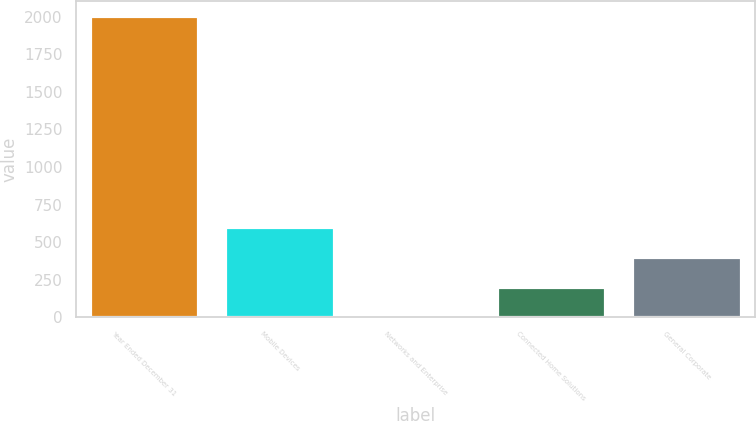Convert chart. <chart><loc_0><loc_0><loc_500><loc_500><bar_chart><fcel>Year Ended December 31<fcel>Mobile Devices<fcel>Networks and Enterprise<fcel>Connected Home Solutions<fcel>General Corporate<nl><fcel>2004<fcel>602.6<fcel>2<fcel>202.2<fcel>402.4<nl></chart> 